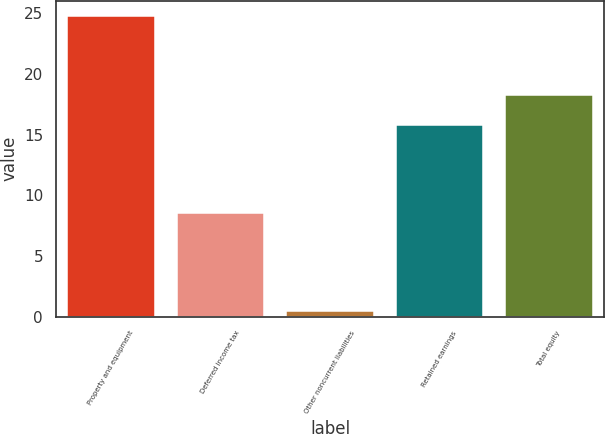Convert chart to OTSL. <chart><loc_0><loc_0><loc_500><loc_500><bar_chart><fcel>Property and equipment<fcel>Deferred income tax<fcel>Other noncurrent liabilities<fcel>Retained earnings<fcel>Total equity<nl><fcel>24.8<fcel>8.5<fcel>0.5<fcel>15.8<fcel>18.23<nl></chart> 